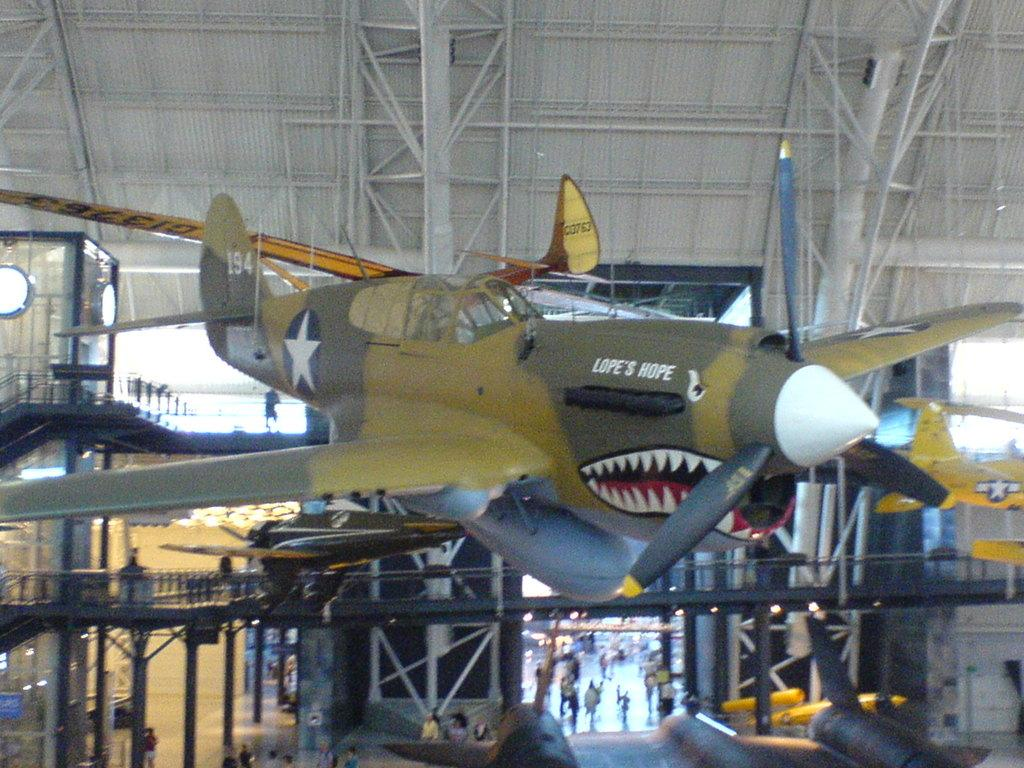<image>
Offer a succinct explanation of the picture presented. A plane with a face painted on it is called Lope's Hope. 